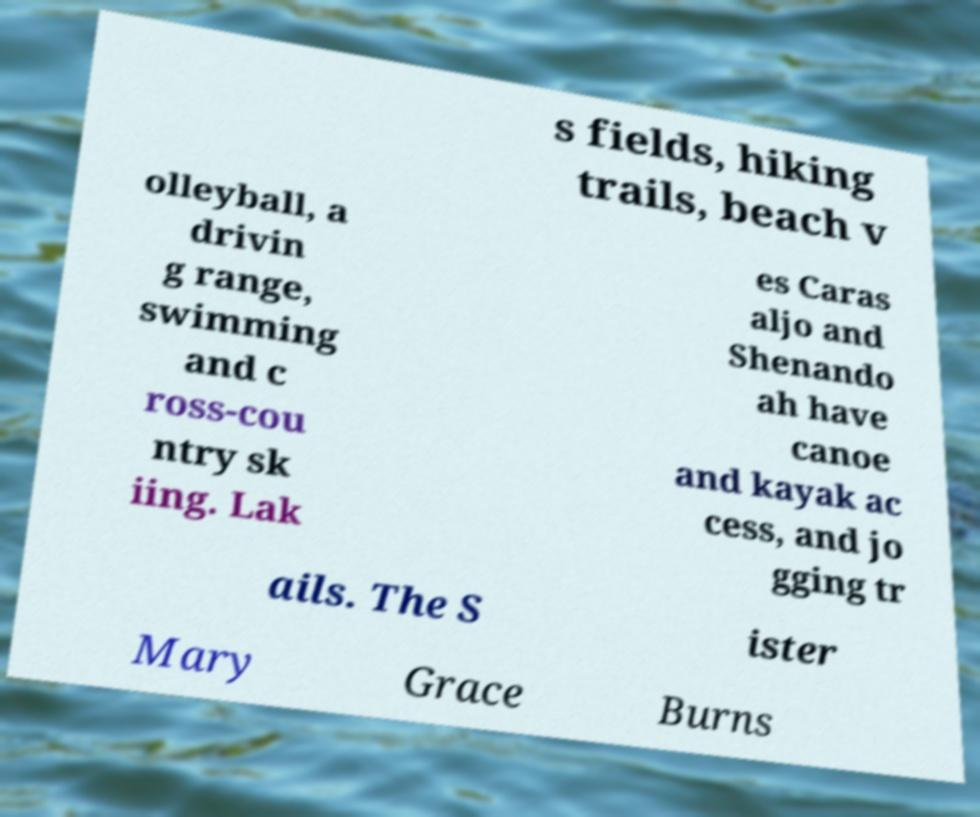What messages or text are displayed in this image? I need them in a readable, typed format. s fields, hiking trails, beach v olleyball, a drivin g range, swimming and c ross-cou ntry sk iing. Lak es Caras aljo and Shenando ah have canoe and kayak ac cess, and jo gging tr ails. The S ister Mary Grace Burns 